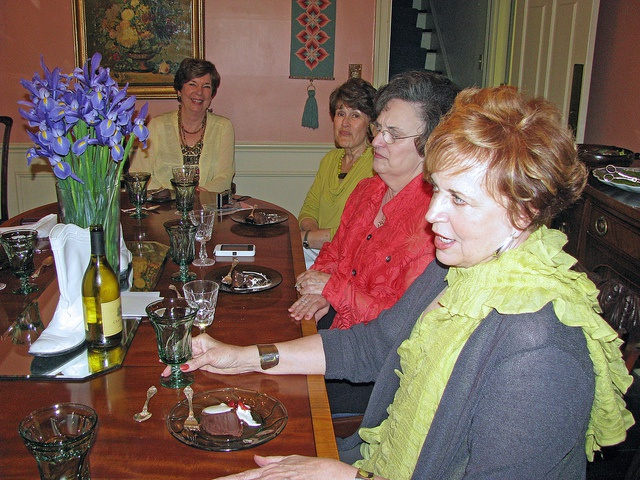Describe the objects in this image and their specific colors. I can see people in brown, gray, khaki, and tan tones, dining table in brown, maroon, and black tones, people in brown tones, potted plant in brown, blue, gray, black, and darkgreen tones, and people in brown, tan, black, and maroon tones in this image. 